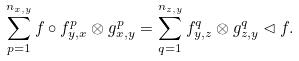Convert formula to latex. <formula><loc_0><loc_0><loc_500><loc_500>\sum _ { p = 1 } ^ { n _ { x , y } } f \circ f _ { y , x } ^ { p } \otimes g _ { x , y } ^ { p } = \sum _ { q = 1 } ^ { n _ { z , y } } f _ { y , z } ^ { q } \otimes g _ { z , y } ^ { q } \lhd f .</formula> 